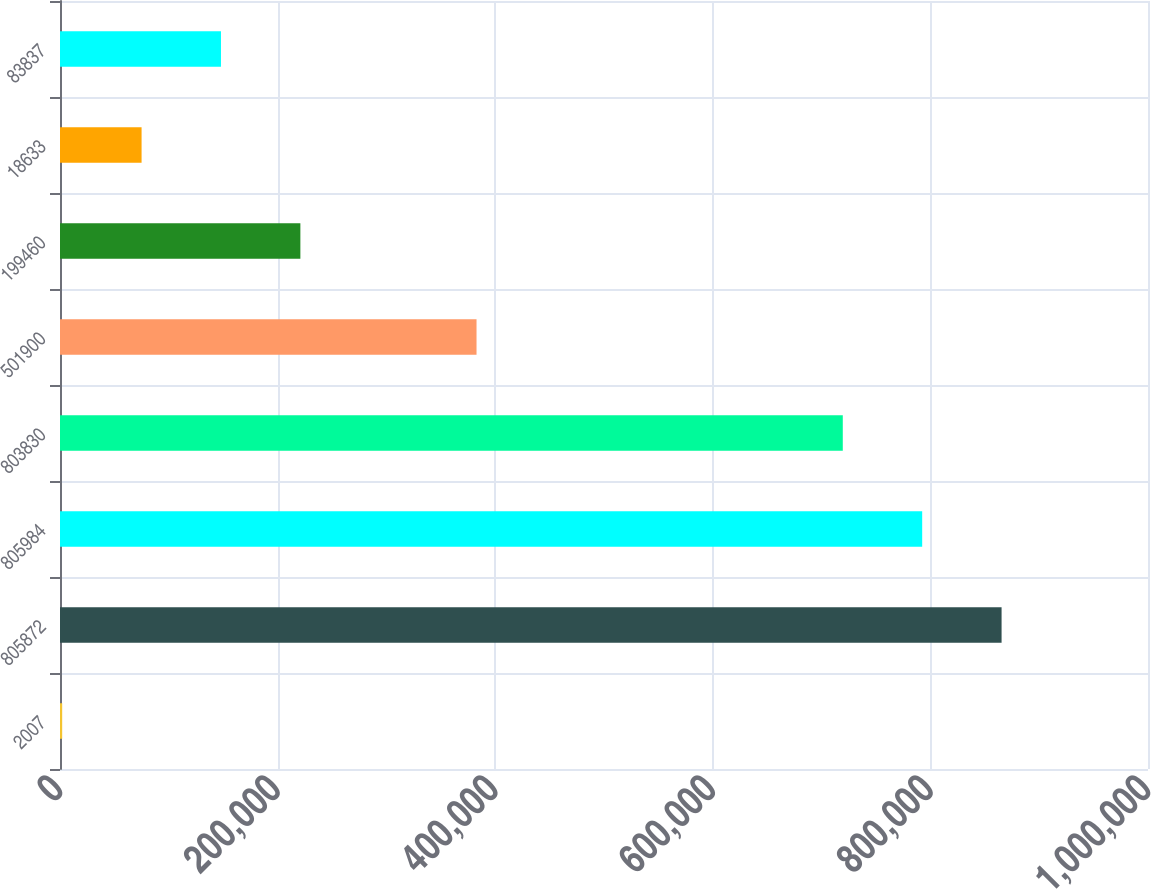<chart> <loc_0><loc_0><loc_500><loc_500><bar_chart><fcel>2007<fcel>805872<fcel>805984<fcel>803830<fcel>501900<fcel>199460<fcel>18633<fcel>83837<nl><fcel>2006<fcel>865423<fcel>792449<fcel>719475<fcel>382839<fcel>220928<fcel>74979.9<fcel>147954<nl></chart> 